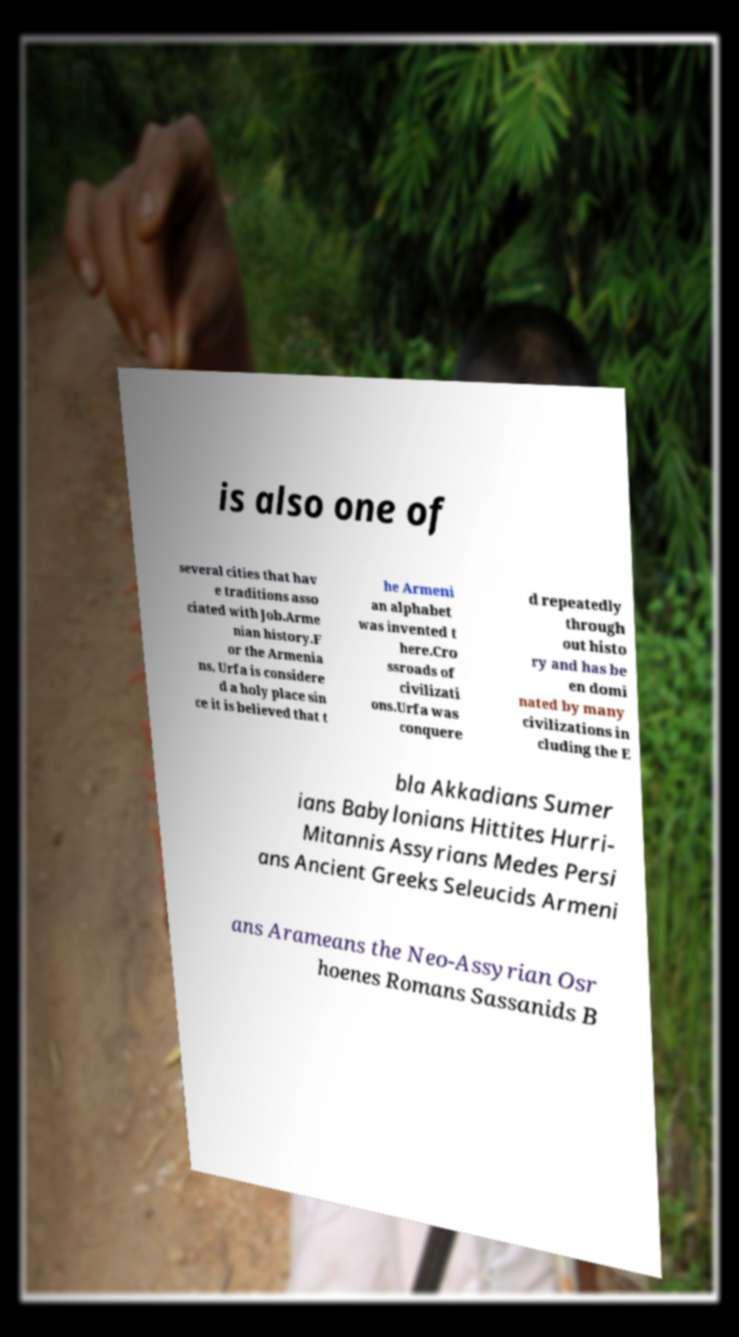Can you read and provide the text displayed in the image?This photo seems to have some interesting text. Can you extract and type it out for me? is also one of several cities that hav e traditions asso ciated with Job.Arme nian history.F or the Armenia ns, Urfa is considere d a holy place sin ce it is believed that t he Armeni an alphabet was invented t here.Cro ssroads of civilizati ons.Urfa was conquere d repeatedly through out histo ry and has be en domi nated by many civilizations in cluding the E bla Akkadians Sumer ians Babylonians Hittites Hurri- Mitannis Assyrians Medes Persi ans Ancient Greeks Seleucids Armeni ans Arameans the Neo-Assyrian Osr hoenes Romans Sassanids B 